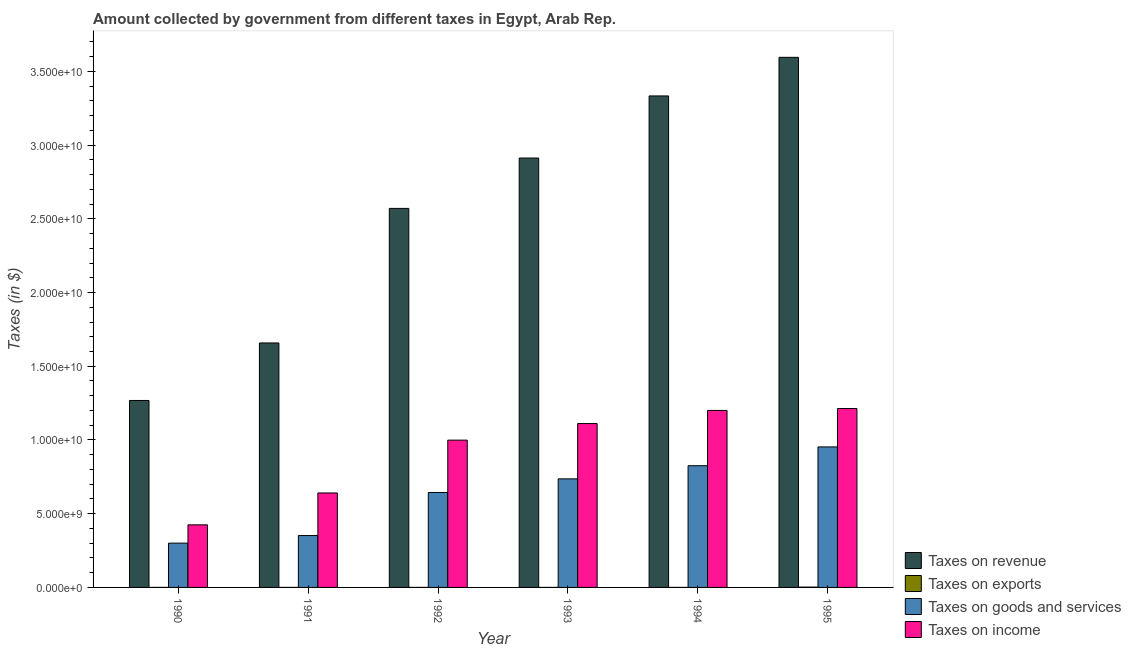Are the number of bars per tick equal to the number of legend labels?
Provide a short and direct response. Yes. What is the label of the 4th group of bars from the left?
Your answer should be compact. 1993. In how many cases, is the number of bars for a given year not equal to the number of legend labels?
Give a very brief answer. 0. What is the amount collected as tax on income in 1993?
Ensure brevity in your answer.  1.11e+1. Across all years, what is the maximum amount collected as tax on goods?
Offer a terse response. 9.53e+09. Across all years, what is the minimum amount collected as tax on revenue?
Your answer should be compact. 1.27e+1. What is the total amount collected as tax on goods in the graph?
Your response must be concise. 3.81e+1. What is the difference between the amount collected as tax on income in 1994 and that in 1995?
Give a very brief answer. -1.30e+08. What is the difference between the amount collected as tax on exports in 1993 and the amount collected as tax on revenue in 1994?
Your answer should be very brief. -5.00e+05. What is the average amount collected as tax on revenue per year?
Your response must be concise. 2.56e+1. In the year 1991, what is the difference between the amount collected as tax on income and amount collected as tax on goods?
Give a very brief answer. 0. In how many years, is the amount collected as tax on exports greater than 25000000000 $?
Offer a terse response. 0. What is the ratio of the amount collected as tax on revenue in 1992 to that in 1993?
Your response must be concise. 0.88. Is the amount collected as tax on exports in 1993 less than that in 1995?
Make the answer very short. Yes. What is the difference between the highest and the second highest amount collected as tax on income?
Your answer should be compact. 1.30e+08. What is the difference between the highest and the lowest amount collected as tax on exports?
Your answer should be very brief. 2.06e+07. Is the sum of the amount collected as tax on exports in 1994 and 1995 greater than the maximum amount collected as tax on goods across all years?
Offer a very short reply. Yes. Is it the case that in every year, the sum of the amount collected as tax on goods and amount collected as tax on revenue is greater than the sum of amount collected as tax on exports and amount collected as tax on income?
Your answer should be compact. No. What does the 1st bar from the left in 1990 represents?
Provide a short and direct response. Taxes on revenue. What does the 1st bar from the right in 1991 represents?
Your answer should be very brief. Taxes on income. How many bars are there?
Give a very brief answer. 24. What is the difference between two consecutive major ticks on the Y-axis?
Provide a succinct answer. 5.00e+09. Does the graph contain grids?
Make the answer very short. No. How are the legend labels stacked?
Offer a very short reply. Vertical. What is the title of the graph?
Ensure brevity in your answer.  Amount collected by government from different taxes in Egypt, Arab Rep. What is the label or title of the X-axis?
Ensure brevity in your answer.  Year. What is the label or title of the Y-axis?
Provide a succinct answer. Taxes (in $). What is the Taxes (in $) of Taxes on revenue in 1990?
Offer a very short reply. 1.27e+1. What is the Taxes (in $) in Taxes on exports in 1990?
Your answer should be very brief. 2.00e+06. What is the Taxes (in $) in Taxes on goods and services in 1990?
Keep it short and to the point. 3.00e+09. What is the Taxes (in $) of Taxes on income in 1990?
Your answer should be very brief. 4.24e+09. What is the Taxes (in $) in Taxes on revenue in 1991?
Ensure brevity in your answer.  1.66e+1. What is the Taxes (in $) in Taxes on exports in 1991?
Your response must be concise. 1.00e+06. What is the Taxes (in $) in Taxes on goods and services in 1991?
Ensure brevity in your answer.  3.52e+09. What is the Taxes (in $) in Taxes on income in 1991?
Provide a succinct answer. 6.41e+09. What is the Taxes (in $) of Taxes on revenue in 1992?
Provide a short and direct response. 2.57e+1. What is the Taxes (in $) in Taxes on exports in 1992?
Give a very brief answer. 2.00e+06. What is the Taxes (in $) of Taxes on goods and services in 1992?
Provide a short and direct response. 6.44e+09. What is the Taxes (in $) in Taxes on income in 1992?
Your answer should be very brief. 9.99e+09. What is the Taxes (in $) of Taxes on revenue in 1993?
Your answer should be very brief. 2.91e+1. What is the Taxes (in $) of Taxes on goods and services in 1993?
Give a very brief answer. 7.36e+09. What is the Taxes (in $) in Taxes on income in 1993?
Your answer should be very brief. 1.11e+1. What is the Taxes (in $) in Taxes on revenue in 1994?
Provide a short and direct response. 3.33e+1. What is the Taxes (in $) in Taxes on exports in 1994?
Offer a very short reply. 1.50e+06. What is the Taxes (in $) of Taxes on goods and services in 1994?
Provide a succinct answer. 8.26e+09. What is the Taxes (in $) of Taxes on income in 1994?
Ensure brevity in your answer.  1.20e+1. What is the Taxes (in $) of Taxes on revenue in 1995?
Your answer should be compact. 3.60e+1. What is the Taxes (in $) of Taxes on exports in 1995?
Your answer should be compact. 2.16e+07. What is the Taxes (in $) in Taxes on goods and services in 1995?
Your answer should be compact. 9.53e+09. What is the Taxes (in $) in Taxes on income in 1995?
Offer a terse response. 1.21e+1. Across all years, what is the maximum Taxes (in $) in Taxes on revenue?
Provide a short and direct response. 3.60e+1. Across all years, what is the maximum Taxes (in $) of Taxes on exports?
Your answer should be very brief. 2.16e+07. Across all years, what is the maximum Taxes (in $) of Taxes on goods and services?
Your answer should be compact. 9.53e+09. Across all years, what is the maximum Taxes (in $) of Taxes on income?
Offer a very short reply. 1.21e+1. Across all years, what is the minimum Taxes (in $) of Taxes on revenue?
Your answer should be compact. 1.27e+1. Across all years, what is the minimum Taxes (in $) of Taxes on exports?
Provide a short and direct response. 1.00e+06. Across all years, what is the minimum Taxes (in $) of Taxes on goods and services?
Your response must be concise. 3.00e+09. Across all years, what is the minimum Taxes (in $) of Taxes on income?
Offer a terse response. 4.24e+09. What is the total Taxes (in $) in Taxes on revenue in the graph?
Your answer should be compact. 1.53e+11. What is the total Taxes (in $) of Taxes on exports in the graph?
Keep it short and to the point. 2.91e+07. What is the total Taxes (in $) of Taxes on goods and services in the graph?
Keep it short and to the point. 3.81e+1. What is the total Taxes (in $) of Taxes on income in the graph?
Provide a succinct answer. 5.59e+1. What is the difference between the Taxes (in $) in Taxes on revenue in 1990 and that in 1991?
Give a very brief answer. -3.90e+09. What is the difference between the Taxes (in $) of Taxes on goods and services in 1990 and that in 1991?
Provide a succinct answer. -5.15e+08. What is the difference between the Taxes (in $) in Taxes on income in 1990 and that in 1991?
Ensure brevity in your answer.  -2.16e+09. What is the difference between the Taxes (in $) in Taxes on revenue in 1990 and that in 1992?
Provide a succinct answer. -1.30e+1. What is the difference between the Taxes (in $) of Taxes on goods and services in 1990 and that in 1992?
Provide a succinct answer. -3.44e+09. What is the difference between the Taxes (in $) of Taxes on income in 1990 and that in 1992?
Keep it short and to the point. -5.74e+09. What is the difference between the Taxes (in $) of Taxes on revenue in 1990 and that in 1993?
Make the answer very short. -1.64e+1. What is the difference between the Taxes (in $) in Taxes on goods and services in 1990 and that in 1993?
Offer a very short reply. -4.36e+09. What is the difference between the Taxes (in $) in Taxes on income in 1990 and that in 1993?
Keep it short and to the point. -6.87e+09. What is the difference between the Taxes (in $) of Taxes on revenue in 1990 and that in 1994?
Offer a terse response. -2.07e+1. What is the difference between the Taxes (in $) of Taxes on exports in 1990 and that in 1994?
Give a very brief answer. 5.00e+05. What is the difference between the Taxes (in $) of Taxes on goods and services in 1990 and that in 1994?
Your answer should be compact. -5.25e+09. What is the difference between the Taxes (in $) of Taxes on income in 1990 and that in 1994?
Your response must be concise. -7.76e+09. What is the difference between the Taxes (in $) of Taxes on revenue in 1990 and that in 1995?
Offer a very short reply. -2.33e+1. What is the difference between the Taxes (in $) of Taxes on exports in 1990 and that in 1995?
Offer a terse response. -1.96e+07. What is the difference between the Taxes (in $) in Taxes on goods and services in 1990 and that in 1995?
Offer a terse response. -6.52e+09. What is the difference between the Taxes (in $) of Taxes on income in 1990 and that in 1995?
Offer a very short reply. -7.89e+09. What is the difference between the Taxes (in $) of Taxes on revenue in 1991 and that in 1992?
Your response must be concise. -9.13e+09. What is the difference between the Taxes (in $) of Taxes on goods and services in 1991 and that in 1992?
Keep it short and to the point. -2.92e+09. What is the difference between the Taxes (in $) of Taxes on income in 1991 and that in 1992?
Keep it short and to the point. -3.58e+09. What is the difference between the Taxes (in $) of Taxes on revenue in 1991 and that in 1993?
Your answer should be compact. -1.25e+1. What is the difference between the Taxes (in $) in Taxes on exports in 1991 and that in 1993?
Provide a succinct answer. 0. What is the difference between the Taxes (in $) of Taxes on goods and services in 1991 and that in 1993?
Your answer should be very brief. -3.84e+09. What is the difference between the Taxes (in $) in Taxes on income in 1991 and that in 1993?
Ensure brevity in your answer.  -4.71e+09. What is the difference between the Taxes (in $) in Taxes on revenue in 1991 and that in 1994?
Offer a terse response. -1.68e+1. What is the difference between the Taxes (in $) in Taxes on exports in 1991 and that in 1994?
Provide a succinct answer. -5.00e+05. What is the difference between the Taxes (in $) of Taxes on goods and services in 1991 and that in 1994?
Your answer should be compact. -4.74e+09. What is the difference between the Taxes (in $) in Taxes on income in 1991 and that in 1994?
Give a very brief answer. -5.60e+09. What is the difference between the Taxes (in $) in Taxes on revenue in 1991 and that in 1995?
Your response must be concise. -1.94e+1. What is the difference between the Taxes (in $) of Taxes on exports in 1991 and that in 1995?
Offer a terse response. -2.06e+07. What is the difference between the Taxes (in $) of Taxes on goods and services in 1991 and that in 1995?
Keep it short and to the point. -6.01e+09. What is the difference between the Taxes (in $) of Taxes on income in 1991 and that in 1995?
Offer a terse response. -5.73e+09. What is the difference between the Taxes (in $) of Taxes on revenue in 1992 and that in 1993?
Provide a succinct answer. -3.42e+09. What is the difference between the Taxes (in $) of Taxes on exports in 1992 and that in 1993?
Keep it short and to the point. 1.00e+06. What is the difference between the Taxes (in $) of Taxes on goods and services in 1992 and that in 1993?
Your answer should be very brief. -9.24e+08. What is the difference between the Taxes (in $) of Taxes on income in 1992 and that in 1993?
Provide a succinct answer. -1.12e+09. What is the difference between the Taxes (in $) in Taxes on revenue in 1992 and that in 1994?
Offer a very short reply. -7.63e+09. What is the difference between the Taxes (in $) in Taxes on goods and services in 1992 and that in 1994?
Offer a terse response. -1.82e+09. What is the difference between the Taxes (in $) of Taxes on income in 1992 and that in 1994?
Provide a short and direct response. -2.02e+09. What is the difference between the Taxes (in $) of Taxes on revenue in 1992 and that in 1995?
Your answer should be very brief. -1.02e+1. What is the difference between the Taxes (in $) of Taxes on exports in 1992 and that in 1995?
Provide a short and direct response. -1.96e+07. What is the difference between the Taxes (in $) of Taxes on goods and services in 1992 and that in 1995?
Offer a very short reply. -3.09e+09. What is the difference between the Taxes (in $) in Taxes on income in 1992 and that in 1995?
Provide a short and direct response. -2.14e+09. What is the difference between the Taxes (in $) of Taxes on revenue in 1993 and that in 1994?
Provide a short and direct response. -4.21e+09. What is the difference between the Taxes (in $) of Taxes on exports in 1993 and that in 1994?
Keep it short and to the point. -5.00e+05. What is the difference between the Taxes (in $) of Taxes on goods and services in 1993 and that in 1994?
Provide a succinct answer. -8.92e+08. What is the difference between the Taxes (in $) in Taxes on income in 1993 and that in 1994?
Offer a terse response. -8.90e+08. What is the difference between the Taxes (in $) in Taxes on revenue in 1993 and that in 1995?
Your answer should be very brief. -6.83e+09. What is the difference between the Taxes (in $) of Taxes on exports in 1993 and that in 1995?
Your answer should be very brief. -2.06e+07. What is the difference between the Taxes (in $) in Taxes on goods and services in 1993 and that in 1995?
Ensure brevity in your answer.  -2.17e+09. What is the difference between the Taxes (in $) in Taxes on income in 1993 and that in 1995?
Offer a terse response. -1.02e+09. What is the difference between the Taxes (in $) in Taxes on revenue in 1994 and that in 1995?
Give a very brief answer. -2.62e+09. What is the difference between the Taxes (in $) of Taxes on exports in 1994 and that in 1995?
Offer a very short reply. -2.01e+07. What is the difference between the Taxes (in $) in Taxes on goods and services in 1994 and that in 1995?
Ensure brevity in your answer.  -1.27e+09. What is the difference between the Taxes (in $) of Taxes on income in 1994 and that in 1995?
Provide a short and direct response. -1.30e+08. What is the difference between the Taxes (in $) of Taxes on revenue in 1990 and the Taxes (in $) of Taxes on exports in 1991?
Provide a short and direct response. 1.27e+1. What is the difference between the Taxes (in $) of Taxes on revenue in 1990 and the Taxes (in $) of Taxes on goods and services in 1991?
Offer a terse response. 9.16e+09. What is the difference between the Taxes (in $) in Taxes on revenue in 1990 and the Taxes (in $) in Taxes on income in 1991?
Keep it short and to the point. 6.27e+09. What is the difference between the Taxes (in $) in Taxes on exports in 1990 and the Taxes (in $) in Taxes on goods and services in 1991?
Ensure brevity in your answer.  -3.52e+09. What is the difference between the Taxes (in $) of Taxes on exports in 1990 and the Taxes (in $) of Taxes on income in 1991?
Offer a very short reply. -6.40e+09. What is the difference between the Taxes (in $) in Taxes on goods and services in 1990 and the Taxes (in $) in Taxes on income in 1991?
Keep it short and to the point. -3.40e+09. What is the difference between the Taxes (in $) in Taxes on revenue in 1990 and the Taxes (in $) in Taxes on exports in 1992?
Ensure brevity in your answer.  1.27e+1. What is the difference between the Taxes (in $) in Taxes on revenue in 1990 and the Taxes (in $) in Taxes on goods and services in 1992?
Provide a short and direct response. 6.24e+09. What is the difference between the Taxes (in $) of Taxes on revenue in 1990 and the Taxes (in $) of Taxes on income in 1992?
Offer a terse response. 2.69e+09. What is the difference between the Taxes (in $) of Taxes on exports in 1990 and the Taxes (in $) of Taxes on goods and services in 1992?
Provide a short and direct response. -6.44e+09. What is the difference between the Taxes (in $) in Taxes on exports in 1990 and the Taxes (in $) in Taxes on income in 1992?
Give a very brief answer. -9.99e+09. What is the difference between the Taxes (in $) in Taxes on goods and services in 1990 and the Taxes (in $) in Taxes on income in 1992?
Offer a very short reply. -6.98e+09. What is the difference between the Taxes (in $) of Taxes on revenue in 1990 and the Taxes (in $) of Taxes on exports in 1993?
Give a very brief answer. 1.27e+1. What is the difference between the Taxes (in $) of Taxes on revenue in 1990 and the Taxes (in $) of Taxes on goods and services in 1993?
Ensure brevity in your answer.  5.32e+09. What is the difference between the Taxes (in $) of Taxes on revenue in 1990 and the Taxes (in $) of Taxes on income in 1993?
Ensure brevity in your answer.  1.56e+09. What is the difference between the Taxes (in $) in Taxes on exports in 1990 and the Taxes (in $) in Taxes on goods and services in 1993?
Ensure brevity in your answer.  -7.36e+09. What is the difference between the Taxes (in $) of Taxes on exports in 1990 and the Taxes (in $) of Taxes on income in 1993?
Keep it short and to the point. -1.11e+1. What is the difference between the Taxes (in $) of Taxes on goods and services in 1990 and the Taxes (in $) of Taxes on income in 1993?
Provide a succinct answer. -8.11e+09. What is the difference between the Taxes (in $) in Taxes on revenue in 1990 and the Taxes (in $) in Taxes on exports in 1994?
Your answer should be compact. 1.27e+1. What is the difference between the Taxes (in $) of Taxes on revenue in 1990 and the Taxes (in $) of Taxes on goods and services in 1994?
Your answer should be very brief. 4.42e+09. What is the difference between the Taxes (in $) of Taxes on revenue in 1990 and the Taxes (in $) of Taxes on income in 1994?
Offer a very short reply. 6.75e+08. What is the difference between the Taxes (in $) in Taxes on exports in 1990 and the Taxes (in $) in Taxes on goods and services in 1994?
Give a very brief answer. -8.25e+09. What is the difference between the Taxes (in $) in Taxes on exports in 1990 and the Taxes (in $) in Taxes on income in 1994?
Keep it short and to the point. -1.20e+1. What is the difference between the Taxes (in $) in Taxes on goods and services in 1990 and the Taxes (in $) in Taxes on income in 1994?
Provide a succinct answer. -9.00e+09. What is the difference between the Taxes (in $) of Taxes on revenue in 1990 and the Taxes (in $) of Taxes on exports in 1995?
Give a very brief answer. 1.27e+1. What is the difference between the Taxes (in $) of Taxes on revenue in 1990 and the Taxes (in $) of Taxes on goods and services in 1995?
Keep it short and to the point. 3.15e+09. What is the difference between the Taxes (in $) of Taxes on revenue in 1990 and the Taxes (in $) of Taxes on income in 1995?
Provide a short and direct response. 5.45e+08. What is the difference between the Taxes (in $) in Taxes on exports in 1990 and the Taxes (in $) in Taxes on goods and services in 1995?
Your answer should be compact. -9.53e+09. What is the difference between the Taxes (in $) of Taxes on exports in 1990 and the Taxes (in $) of Taxes on income in 1995?
Keep it short and to the point. -1.21e+1. What is the difference between the Taxes (in $) of Taxes on goods and services in 1990 and the Taxes (in $) of Taxes on income in 1995?
Keep it short and to the point. -9.13e+09. What is the difference between the Taxes (in $) in Taxes on revenue in 1991 and the Taxes (in $) in Taxes on exports in 1992?
Provide a short and direct response. 1.66e+1. What is the difference between the Taxes (in $) of Taxes on revenue in 1991 and the Taxes (in $) of Taxes on goods and services in 1992?
Keep it short and to the point. 1.01e+1. What is the difference between the Taxes (in $) of Taxes on revenue in 1991 and the Taxes (in $) of Taxes on income in 1992?
Keep it short and to the point. 6.59e+09. What is the difference between the Taxes (in $) of Taxes on exports in 1991 and the Taxes (in $) of Taxes on goods and services in 1992?
Your answer should be very brief. -6.44e+09. What is the difference between the Taxes (in $) of Taxes on exports in 1991 and the Taxes (in $) of Taxes on income in 1992?
Make the answer very short. -9.99e+09. What is the difference between the Taxes (in $) of Taxes on goods and services in 1991 and the Taxes (in $) of Taxes on income in 1992?
Ensure brevity in your answer.  -6.47e+09. What is the difference between the Taxes (in $) in Taxes on revenue in 1991 and the Taxes (in $) in Taxes on exports in 1993?
Keep it short and to the point. 1.66e+1. What is the difference between the Taxes (in $) in Taxes on revenue in 1991 and the Taxes (in $) in Taxes on goods and services in 1993?
Offer a terse response. 9.22e+09. What is the difference between the Taxes (in $) in Taxes on revenue in 1991 and the Taxes (in $) in Taxes on income in 1993?
Give a very brief answer. 5.47e+09. What is the difference between the Taxes (in $) in Taxes on exports in 1991 and the Taxes (in $) in Taxes on goods and services in 1993?
Offer a terse response. -7.36e+09. What is the difference between the Taxes (in $) of Taxes on exports in 1991 and the Taxes (in $) of Taxes on income in 1993?
Ensure brevity in your answer.  -1.11e+1. What is the difference between the Taxes (in $) in Taxes on goods and services in 1991 and the Taxes (in $) in Taxes on income in 1993?
Your answer should be compact. -7.60e+09. What is the difference between the Taxes (in $) in Taxes on revenue in 1991 and the Taxes (in $) in Taxes on exports in 1994?
Offer a terse response. 1.66e+1. What is the difference between the Taxes (in $) in Taxes on revenue in 1991 and the Taxes (in $) in Taxes on goods and services in 1994?
Ensure brevity in your answer.  8.32e+09. What is the difference between the Taxes (in $) in Taxes on revenue in 1991 and the Taxes (in $) in Taxes on income in 1994?
Provide a succinct answer. 4.58e+09. What is the difference between the Taxes (in $) of Taxes on exports in 1991 and the Taxes (in $) of Taxes on goods and services in 1994?
Make the answer very short. -8.25e+09. What is the difference between the Taxes (in $) of Taxes on exports in 1991 and the Taxes (in $) of Taxes on income in 1994?
Offer a very short reply. -1.20e+1. What is the difference between the Taxes (in $) of Taxes on goods and services in 1991 and the Taxes (in $) of Taxes on income in 1994?
Your answer should be very brief. -8.48e+09. What is the difference between the Taxes (in $) of Taxes on revenue in 1991 and the Taxes (in $) of Taxes on exports in 1995?
Your response must be concise. 1.66e+1. What is the difference between the Taxes (in $) in Taxes on revenue in 1991 and the Taxes (in $) in Taxes on goods and services in 1995?
Your answer should be very brief. 7.05e+09. What is the difference between the Taxes (in $) of Taxes on revenue in 1991 and the Taxes (in $) of Taxes on income in 1995?
Ensure brevity in your answer.  4.45e+09. What is the difference between the Taxes (in $) of Taxes on exports in 1991 and the Taxes (in $) of Taxes on goods and services in 1995?
Keep it short and to the point. -9.53e+09. What is the difference between the Taxes (in $) of Taxes on exports in 1991 and the Taxes (in $) of Taxes on income in 1995?
Ensure brevity in your answer.  -1.21e+1. What is the difference between the Taxes (in $) of Taxes on goods and services in 1991 and the Taxes (in $) of Taxes on income in 1995?
Your response must be concise. -8.62e+09. What is the difference between the Taxes (in $) in Taxes on revenue in 1992 and the Taxes (in $) in Taxes on exports in 1993?
Your response must be concise. 2.57e+1. What is the difference between the Taxes (in $) of Taxes on revenue in 1992 and the Taxes (in $) of Taxes on goods and services in 1993?
Make the answer very short. 1.83e+1. What is the difference between the Taxes (in $) of Taxes on revenue in 1992 and the Taxes (in $) of Taxes on income in 1993?
Offer a terse response. 1.46e+1. What is the difference between the Taxes (in $) of Taxes on exports in 1992 and the Taxes (in $) of Taxes on goods and services in 1993?
Offer a terse response. -7.36e+09. What is the difference between the Taxes (in $) of Taxes on exports in 1992 and the Taxes (in $) of Taxes on income in 1993?
Keep it short and to the point. -1.11e+1. What is the difference between the Taxes (in $) of Taxes on goods and services in 1992 and the Taxes (in $) of Taxes on income in 1993?
Provide a short and direct response. -4.68e+09. What is the difference between the Taxes (in $) of Taxes on revenue in 1992 and the Taxes (in $) of Taxes on exports in 1994?
Your response must be concise. 2.57e+1. What is the difference between the Taxes (in $) of Taxes on revenue in 1992 and the Taxes (in $) of Taxes on goods and services in 1994?
Keep it short and to the point. 1.75e+1. What is the difference between the Taxes (in $) in Taxes on revenue in 1992 and the Taxes (in $) in Taxes on income in 1994?
Offer a terse response. 1.37e+1. What is the difference between the Taxes (in $) in Taxes on exports in 1992 and the Taxes (in $) in Taxes on goods and services in 1994?
Your response must be concise. -8.25e+09. What is the difference between the Taxes (in $) in Taxes on exports in 1992 and the Taxes (in $) in Taxes on income in 1994?
Your answer should be compact. -1.20e+1. What is the difference between the Taxes (in $) in Taxes on goods and services in 1992 and the Taxes (in $) in Taxes on income in 1994?
Provide a succinct answer. -5.56e+09. What is the difference between the Taxes (in $) in Taxes on revenue in 1992 and the Taxes (in $) in Taxes on exports in 1995?
Your answer should be very brief. 2.57e+1. What is the difference between the Taxes (in $) in Taxes on revenue in 1992 and the Taxes (in $) in Taxes on goods and services in 1995?
Ensure brevity in your answer.  1.62e+1. What is the difference between the Taxes (in $) of Taxes on revenue in 1992 and the Taxes (in $) of Taxes on income in 1995?
Keep it short and to the point. 1.36e+1. What is the difference between the Taxes (in $) in Taxes on exports in 1992 and the Taxes (in $) in Taxes on goods and services in 1995?
Provide a short and direct response. -9.53e+09. What is the difference between the Taxes (in $) of Taxes on exports in 1992 and the Taxes (in $) of Taxes on income in 1995?
Give a very brief answer. -1.21e+1. What is the difference between the Taxes (in $) in Taxes on goods and services in 1992 and the Taxes (in $) in Taxes on income in 1995?
Give a very brief answer. -5.70e+09. What is the difference between the Taxes (in $) in Taxes on revenue in 1993 and the Taxes (in $) in Taxes on exports in 1994?
Your answer should be compact. 2.91e+1. What is the difference between the Taxes (in $) in Taxes on revenue in 1993 and the Taxes (in $) in Taxes on goods and services in 1994?
Your answer should be compact. 2.09e+1. What is the difference between the Taxes (in $) in Taxes on revenue in 1993 and the Taxes (in $) in Taxes on income in 1994?
Your response must be concise. 1.71e+1. What is the difference between the Taxes (in $) of Taxes on exports in 1993 and the Taxes (in $) of Taxes on goods and services in 1994?
Provide a succinct answer. -8.25e+09. What is the difference between the Taxes (in $) of Taxes on exports in 1993 and the Taxes (in $) of Taxes on income in 1994?
Keep it short and to the point. -1.20e+1. What is the difference between the Taxes (in $) of Taxes on goods and services in 1993 and the Taxes (in $) of Taxes on income in 1994?
Keep it short and to the point. -4.64e+09. What is the difference between the Taxes (in $) in Taxes on revenue in 1993 and the Taxes (in $) in Taxes on exports in 1995?
Make the answer very short. 2.91e+1. What is the difference between the Taxes (in $) of Taxes on revenue in 1993 and the Taxes (in $) of Taxes on goods and services in 1995?
Provide a succinct answer. 1.96e+1. What is the difference between the Taxes (in $) in Taxes on revenue in 1993 and the Taxes (in $) in Taxes on income in 1995?
Offer a very short reply. 1.70e+1. What is the difference between the Taxes (in $) of Taxes on exports in 1993 and the Taxes (in $) of Taxes on goods and services in 1995?
Offer a very short reply. -9.53e+09. What is the difference between the Taxes (in $) of Taxes on exports in 1993 and the Taxes (in $) of Taxes on income in 1995?
Your answer should be compact. -1.21e+1. What is the difference between the Taxes (in $) in Taxes on goods and services in 1993 and the Taxes (in $) in Taxes on income in 1995?
Your answer should be very brief. -4.77e+09. What is the difference between the Taxes (in $) in Taxes on revenue in 1994 and the Taxes (in $) in Taxes on exports in 1995?
Keep it short and to the point. 3.33e+1. What is the difference between the Taxes (in $) of Taxes on revenue in 1994 and the Taxes (in $) of Taxes on goods and services in 1995?
Give a very brief answer. 2.38e+1. What is the difference between the Taxes (in $) of Taxes on revenue in 1994 and the Taxes (in $) of Taxes on income in 1995?
Your response must be concise. 2.12e+1. What is the difference between the Taxes (in $) in Taxes on exports in 1994 and the Taxes (in $) in Taxes on goods and services in 1995?
Your response must be concise. -9.53e+09. What is the difference between the Taxes (in $) in Taxes on exports in 1994 and the Taxes (in $) in Taxes on income in 1995?
Provide a succinct answer. -1.21e+1. What is the difference between the Taxes (in $) of Taxes on goods and services in 1994 and the Taxes (in $) of Taxes on income in 1995?
Make the answer very short. -3.88e+09. What is the average Taxes (in $) in Taxes on revenue per year?
Provide a succinct answer. 2.56e+1. What is the average Taxes (in $) in Taxes on exports per year?
Provide a short and direct response. 4.85e+06. What is the average Taxes (in $) in Taxes on goods and services per year?
Provide a short and direct response. 6.35e+09. What is the average Taxes (in $) in Taxes on income per year?
Offer a terse response. 9.32e+09. In the year 1990, what is the difference between the Taxes (in $) in Taxes on revenue and Taxes (in $) in Taxes on exports?
Make the answer very short. 1.27e+1. In the year 1990, what is the difference between the Taxes (in $) in Taxes on revenue and Taxes (in $) in Taxes on goods and services?
Your response must be concise. 9.68e+09. In the year 1990, what is the difference between the Taxes (in $) in Taxes on revenue and Taxes (in $) in Taxes on income?
Your answer should be very brief. 8.43e+09. In the year 1990, what is the difference between the Taxes (in $) in Taxes on exports and Taxes (in $) in Taxes on goods and services?
Offer a very short reply. -3.00e+09. In the year 1990, what is the difference between the Taxes (in $) in Taxes on exports and Taxes (in $) in Taxes on income?
Provide a short and direct response. -4.24e+09. In the year 1990, what is the difference between the Taxes (in $) of Taxes on goods and services and Taxes (in $) of Taxes on income?
Your answer should be very brief. -1.24e+09. In the year 1991, what is the difference between the Taxes (in $) in Taxes on revenue and Taxes (in $) in Taxes on exports?
Provide a succinct answer. 1.66e+1. In the year 1991, what is the difference between the Taxes (in $) in Taxes on revenue and Taxes (in $) in Taxes on goods and services?
Make the answer very short. 1.31e+1. In the year 1991, what is the difference between the Taxes (in $) in Taxes on revenue and Taxes (in $) in Taxes on income?
Provide a succinct answer. 1.02e+1. In the year 1991, what is the difference between the Taxes (in $) in Taxes on exports and Taxes (in $) in Taxes on goods and services?
Your answer should be very brief. -3.52e+09. In the year 1991, what is the difference between the Taxes (in $) of Taxes on exports and Taxes (in $) of Taxes on income?
Offer a very short reply. -6.41e+09. In the year 1991, what is the difference between the Taxes (in $) of Taxes on goods and services and Taxes (in $) of Taxes on income?
Keep it short and to the point. -2.89e+09. In the year 1992, what is the difference between the Taxes (in $) in Taxes on revenue and Taxes (in $) in Taxes on exports?
Ensure brevity in your answer.  2.57e+1. In the year 1992, what is the difference between the Taxes (in $) in Taxes on revenue and Taxes (in $) in Taxes on goods and services?
Provide a short and direct response. 1.93e+1. In the year 1992, what is the difference between the Taxes (in $) of Taxes on revenue and Taxes (in $) of Taxes on income?
Provide a succinct answer. 1.57e+1. In the year 1992, what is the difference between the Taxes (in $) in Taxes on exports and Taxes (in $) in Taxes on goods and services?
Your answer should be compact. -6.44e+09. In the year 1992, what is the difference between the Taxes (in $) of Taxes on exports and Taxes (in $) of Taxes on income?
Make the answer very short. -9.99e+09. In the year 1992, what is the difference between the Taxes (in $) of Taxes on goods and services and Taxes (in $) of Taxes on income?
Make the answer very short. -3.55e+09. In the year 1993, what is the difference between the Taxes (in $) in Taxes on revenue and Taxes (in $) in Taxes on exports?
Provide a short and direct response. 2.91e+1. In the year 1993, what is the difference between the Taxes (in $) in Taxes on revenue and Taxes (in $) in Taxes on goods and services?
Your answer should be very brief. 2.18e+1. In the year 1993, what is the difference between the Taxes (in $) of Taxes on revenue and Taxes (in $) of Taxes on income?
Your answer should be compact. 1.80e+1. In the year 1993, what is the difference between the Taxes (in $) of Taxes on exports and Taxes (in $) of Taxes on goods and services?
Provide a succinct answer. -7.36e+09. In the year 1993, what is the difference between the Taxes (in $) in Taxes on exports and Taxes (in $) in Taxes on income?
Make the answer very short. -1.11e+1. In the year 1993, what is the difference between the Taxes (in $) in Taxes on goods and services and Taxes (in $) in Taxes on income?
Your answer should be very brief. -3.75e+09. In the year 1994, what is the difference between the Taxes (in $) in Taxes on revenue and Taxes (in $) in Taxes on exports?
Your answer should be compact. 3.33e+1. In the year 1994, what is the difference between the Taxes (in $) of Taxes on revenue and Taxes (in $) of Taxes on goods and services?
Your answer should be very brief. 2.51e+1. In the year 1994, what is the difference between the Taxes (in $) in Taxes on revenue and Taxes (in $) in Taxes on income?
Your answer should be compact. 2.13e+1. In the year 1994, what is the difference between the Taxes (in $) of Taxes on exports and Taxes (in $) of Taxes on goods and services?
Your response must be concise. -8.25e+09. In the year 1994, what is the difference between the Taxes (in $) in Taxes on exports and Taxes (in $) in Taxes on income?
Your response must be concise. -1.20e+1. In the year 1994, what is the difference between the Taxes (in $) in Taxes on goods and services and Taxes (in $) in Taxes on income?
Give a very brief answer. -3.75e+09. In the year 1995, what is the difference between the Taxes (in $) of Taxes on revenue and Taxes (in $) of Taxes on exports?
Provide a succinct answer. 3.59e+1. In the year 1995, what is the difference between the Taxes (in $) of Taxes on revenue and Taxes (in $) of Taxes on goods and services?
Make the answer very short. 2.64e+1. In the year 1995, what is the difference between the Taxes (in $) of Taxes on revenue and Taxes (in $) of Taxes on income?
Your response must be concise. 2.38e+1. In the year 1995, what is the difference between the Taxes (in $) of Taxes on exports and Taxes (in $) of Taxes on goods and services?
Your answer should be compact. -9.51e+09. In the year 1995, what is the difference between the Taxes (in $) of Taxes on exports and Taxes (in $) of Taxes on income?
Provide a succinct answer. -1.21e+1. In the year 1995, what is the difference between the Taxes (in $) in Taxes on goods and services and Taxes (in $) in Taxes on income?
Provide a succinct answer. -2.60e+09. What is the ratio of the Taxes (in $) of Taxes on revenue in 1990 to that in 1991?
Give a very brief answer. 0.76. What is the ratio of the Taxes (in $) of Taxes on exports in 1990 to that in 1991?
Give a very brief answer. 2. What is the ratio of the Taxes (in $) in Taxes on goods and services in 1990 to that in 1991?
Keep it short and to the point. 0.85. What is the ratio of the Taxes (in $) in Taxes on income in 1990 to that in 1991?
Offer a terse response. 0.66. What is the ratio of the Taxes (in $) in Taxes on revenue in 1990 to that in 1992?
Offer a very short reply. 0.49. What is the ratio of the Taxes (in $) in Taxes on goods and services in 1990 to that in 1992?
Offer a terse response. 0.47. What is the ratio of the Taxes (in $) in Taxes on income in 1990 to that in 1992?
Provide a short and direct response. 0.42. What is the ratio of the Taxes (in $) in Taxes on revenue in 1990 to that in 1993?
Give a very brief answer. 0.44. What is the ratio of the Taxes (in $) of Taxes on exports in 1990 to that in 1993?
Ensure brevity in your answer.  2. What is the ratio of the Taxes (in $) of Taxes on goods and services in 1990 to that in 1993?
Provide a short and direct response. 0.41. What is the ratio of the Taxes (in $) of Taxes on income in 1990 to that in 1993?
Provide a short and direct response. 0.38. What is the ratio of the Taxes (in $) of Taxes on revenue in 1990 to that in 1994?
Offer a terse response. 0.38. What is the ratio of the Taxes (in $) of Taxes on exports in 1990 to that in 1994?
Give a very brief answer. 1.33. What is the ratio of the Taxes (in $) in Taxes on goods and services in 1990 to that in 1994?
Ensure brevity in your answer.  0.36. What is the ratio of the Taxes (in $) of Taxes on income in 1990 to that in 1994?
Your response must be concise. 0.35. What is the ratio of the Taxes (in $) of Taxes on revenue in 1990 to that in 1995?
Ensure brevity in your answer.  0.35. What is the ratio of the Taxes (in $) of Taxes on exports in 1990 to that in 1995?
Your response must be concise. 0.09. What is the ratio of the Taxes (in $) of Taxes on goods and services in 1990 to that in 1995?
Provide a succinct answer. 0.32. What is the ratio of the Taxes (in $) in Taxes on income in 1990 to that in 1995?
Make the answer very short. 0.35. What is the ratio of the Taxes (in $) of Taxes on revenue in 1991 to that in 1992?
Give a very brief answer. 0.65. What is the ratio of the Taxes (in $) in Taxes on exports in 1991 to that in 1992?
Your response must be concise. 0.5. What is the ratio of the Taxes (in $) of Taxes on goods and services in 1991 to that in 1992?
Your response must be concise. 0.55. What is the ratio of the Taxes (in $) in Taxes on income in 1991 to that in 1992?
Your answer should be compact. 0.64. What is the ratio of the Taxes (in $) of Taxes on revenue in 1991 to that in 1993?
Offer a very short reply. 0.57. What is the ratio of the Taxes (in $) in Taxes on goods and services in 1991 to that in 1993?
Your response must be concise. 0.48. What is the ratio of the Taxes (in $) in Taxes on income in 1991 to that in 1993?
Offer a terse response. 0.58. What is the ratio of the Taxes (in $) in Taxes on revenue in 1991 to that in 1994?
Ensure brevity in your answer.  0.5. What is the ratio of the Taxes (in $) of Taxes on exports in 1991 to that in 1994?
Offer a terse response. 0.67. What is the ratio of the Taxes (in $) of Taxes on goods and services in 1991 to that in 1994?
Keep it short and to the point. 0.43. What is the ratio of the Taxes (in $) in Taxes on income in 1991 to that in 1994?
Make the answer very short. 0.53. What is the ratio of the Taxes (in $) in Taxes on revenue in 1991 to that in 1995?
Offer a very short reply. 0.46. What is the ratio of the Taxes (in $) in Taxes on exports in 1991 to that in 1995?
Provide a succinct answer. 0.05. What is the ratio of the Taxes (in $) of Taxes on goods and services in 1991 to that in 1995?
Your answer should be compact. 0.37. What is the ratio of the Taxes (in $) in Taxes on income in 1991 to that in 1995?
Ensure brevity in your answer.  0.53. What is the ratio of the Taxes (in $) in Taxes on revenue in 1992 to that in 1993?
Offer a terse response. 0.88. What is the ratio of the Taxes (in $) of Taxes on goods and services in 1992 to that in 1993?
Offer a very short reply. 0.87. What is the ratio of the Taxes (in $) of Taxes on income in 1992 to that in 1993?
Your answer should be very brief. 0.9. What is the ratio of the Taxes (in $) of Taxes on revenue in 1992 to that in 1994?
Give a very brief answer. 0.77. What is the ratio of the Taxes (in $) in Taxes on goods and services in 1992 to that in 1994?
Offer a terse response. 0.78. What is the ratio of the Taxes (in $) of Taxes on income in 1992 to that in 1994?
Give a very brief answer. 0.83. What is the ratio of the Taxes (in $) in Taxes on revenue in 1992 to that in 1995?
Ensure brevity in your answer.  0.71. What is the ratio of the Taxes (in $) in Taxes on exports in 1992 to that in 1995?
Make the answer very short. 0.09. What is the ratio of the Taxes (in $) in Taxes on goods and services in 1992 to that in 1995?
Your answer should be compact. 0.68. What is the ratio of the Taxes (in $) in Taxes on income in 1992 to that in 1995?
Provide a short and direct response. 0.82. What is the ratio of the Taxes (in $) in Taxes on revenue in 1993 to that in 1994?
Give a very brief answer. 0.87. What is the ratio of the Taxes (in $) of Taxes on exports in 1993 to that in 1994?
Make the answer very short. 0.67. What is the ratio of the Taxes (in $) in Taxes on goods and services in 1993 to that in 1994?
Offer a very short reply. 0.89. What is the ratio of the Taxes (in $) in Taxes on income in 1993 to that in 1994?
Make the answer very short. 0.93. What is the ratio of the Taxes (in $) in Taxes on revenue in 1993 to that in 1995?
Provide a succinct answer. 0.81. What is the ratio of the Taxes (in $) of Taxes on exports in 1993 to that in 1995?
Offer a terse response. 0.05. What is the ratio of the Taxes (in $) of Taxes on goods and services in 1993 to that in 1995?
Give a very brief answer. 0.77. What is the ratio of the Taxes (in $) of Taxes on income in 1993 to that in 1995?
Your response must be concise. 0.92. What is the ratio of the Taxes (in $) of Taxes on revenue in 1994 to that in 1995?
Ensure brevity in your answer.  0.93. What is the ratio of the Taxes (in $) in Taxes on exports in 1994 to that in 1995?
Offer a terse response. 0.07. What is the ratio of the Taxes (in $) of Taxes on goods and services in 1994 to that in 1995?
Your response must be concise. 0.87. What is the ratio of the Taxes (in $) of Taxes on income in 1994 to that in 1995?
Your response must be concise. 0.99. What is the difference between the highest and the second highest Taxes (in $) in Taxes on revenue?
Make the answer very short. 2.62e+09. What is the difference between the highest and the second highest Taxes (in $) in Taxes on exports?
Provide a succinct answer. 1.96e+07. What is the difference between the highest and the second highest Taxes (in $) of Taxes on goods and services?
Provide a short and direct response. 1.27e+09. What is the difference between the highest and the second highest Taxes (in $) of Taxes on income?
Keep it short and to the point. 1.30e+08. What is the difference between the highest and the lowest Taxes (in $) in Taxes on revenue?
Offer a very short reply. 2.33e+1. What is the difference between the highest and the lowest Taxes (in $) in Taxes on exports?
Offer a terse response. 2.06e+07. What is the difference between the highest and the lowest Taxes (in $) of Taxes on goods and services?
Offer a terse response. 6.52e+09. What is the difference between the highest and the lowest Taxes (in $) of Taxes on income?
Offer a terse response. 7.89e+09. 